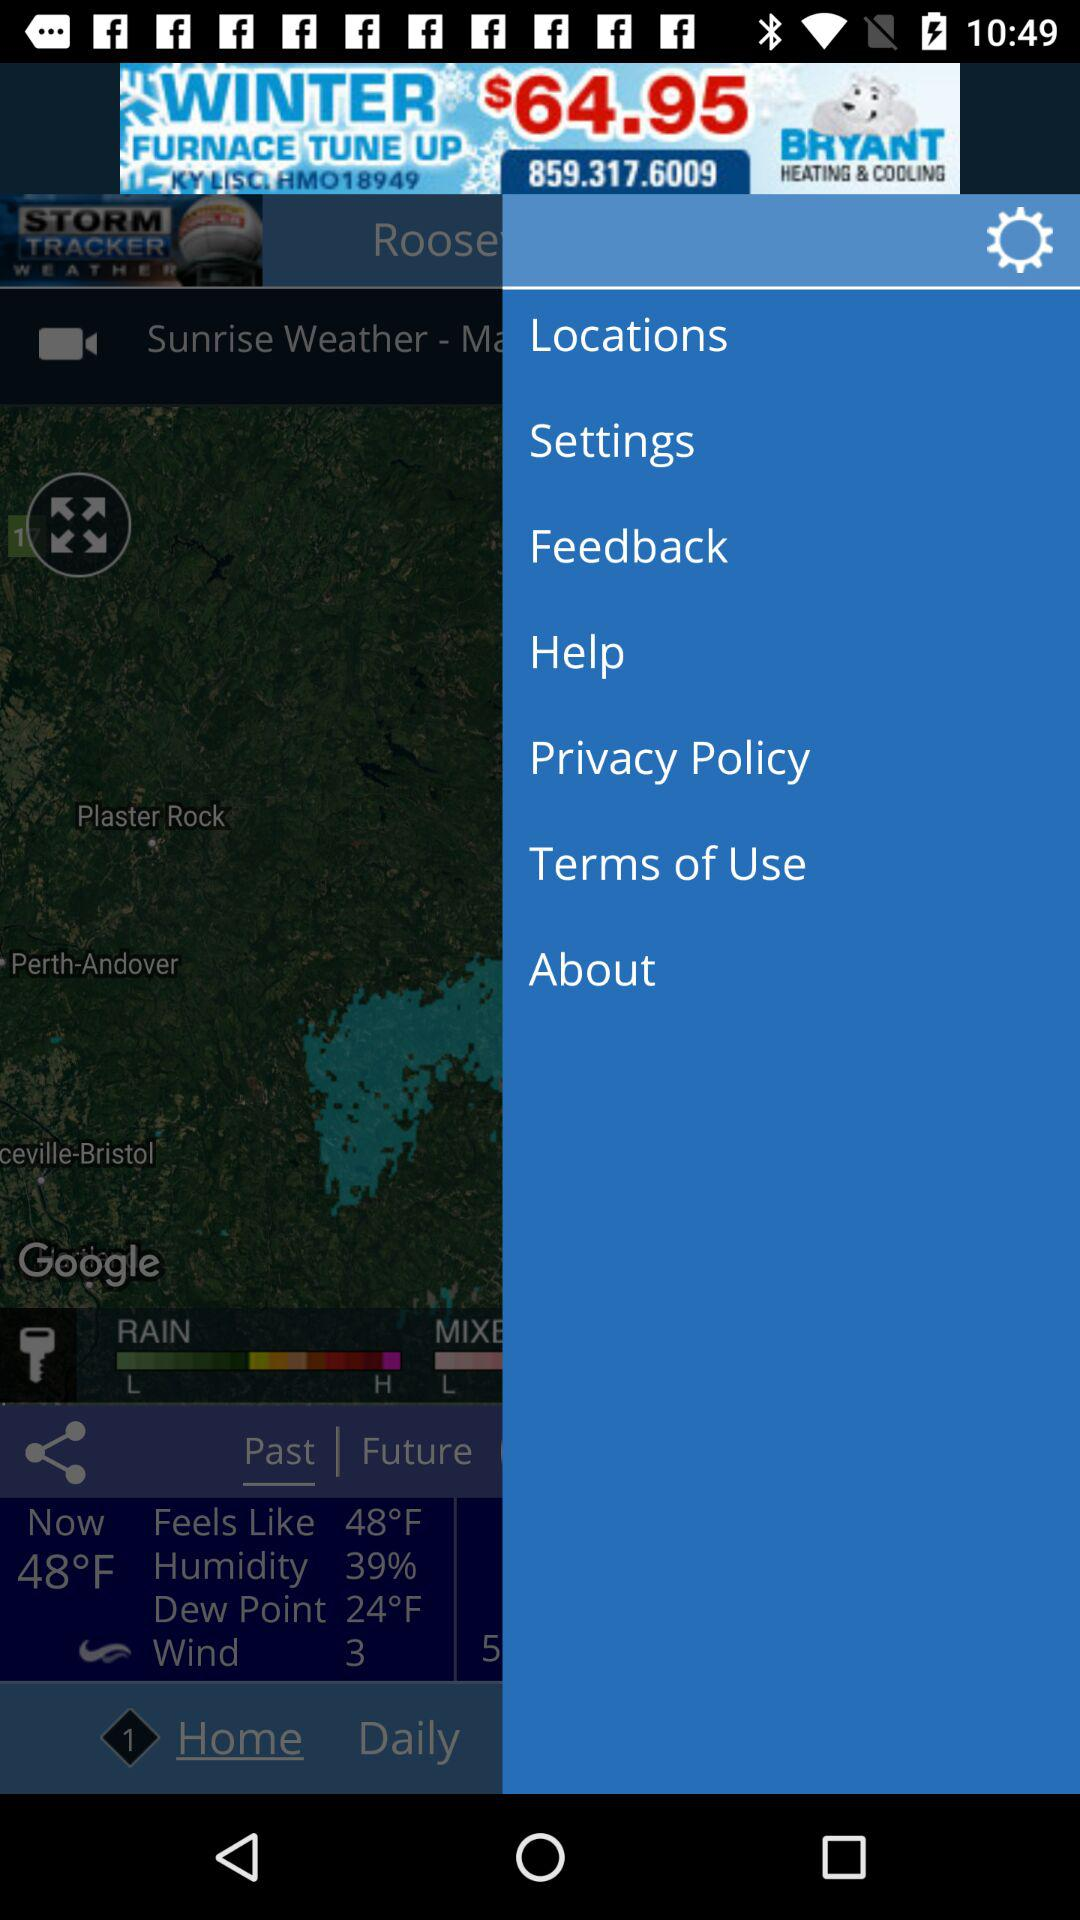Can you tell me more about the weather conditions expected in the area shown in the radar image? The radar image presents an overview of the weather, with a focus on precipitation. Given that we observe areas with light precipitation, it's likely that the weather is relatively calm but may be quite chilly, as indicated by the temperature and dew point information. The humidity is at 39%, coupled with a dew point of 24°F and a temperature of 48°F, this suggests crisp and potentially dry conditions. However, the specific forecast for the area, including whether conditions will worsen or improve, would require more information from the weather service or by observing the radar image over time to track the movement of the precipitation. 